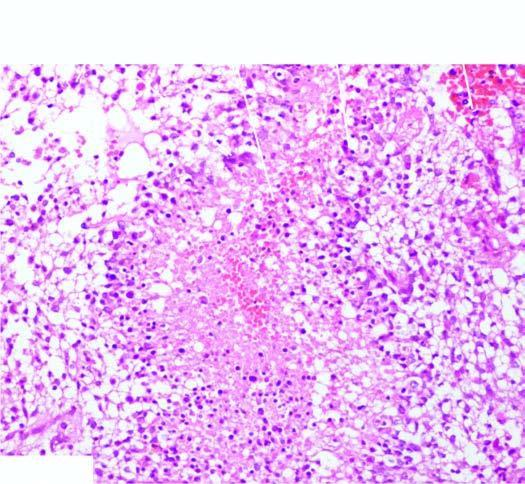does the tumour have areas of necrosis which are surrounded by a palisade layer of tumour cells?
Answer the question using a single word or phrase. Yes 